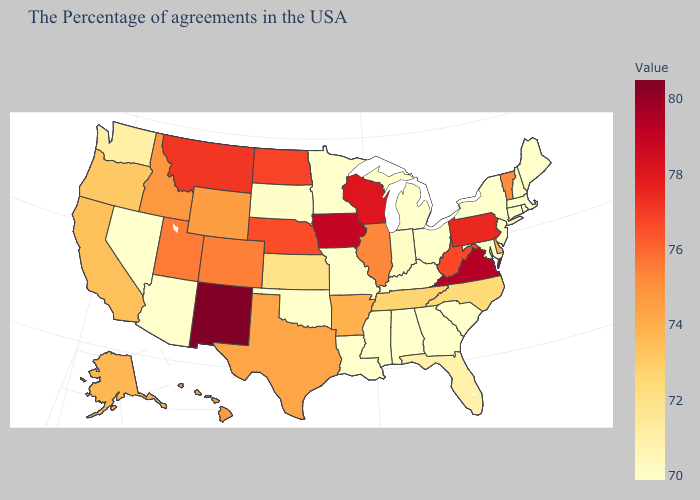Among the states that border New Mexico , does Colorado have the lowest value?
Give a very brief answer. No. Which states have the lowest value in the South?
Short answer required. Maryland, South Carolina, Georgia, Kentucky, Alabama, Mississippi, Louisiana, Oklahoma. Which states have the lowest value in the USA?
Be succinct. Maine, Massachusetts, Rhode Island, New Hampshire, Connecticut, New York, New Jersey, Maryland, South Carolina, Ohio, Georgia, Michigan, Kentucky, Alabama, Mississippi, Louisiana, Missouri, Minnesota, Oklahoma, Arizona, Nevada. Does Hawaii have the highest value in the USA?
Answer briefly. No. Does Tennessee have a lower value than Delaware?
Concise answer only. Yes. 